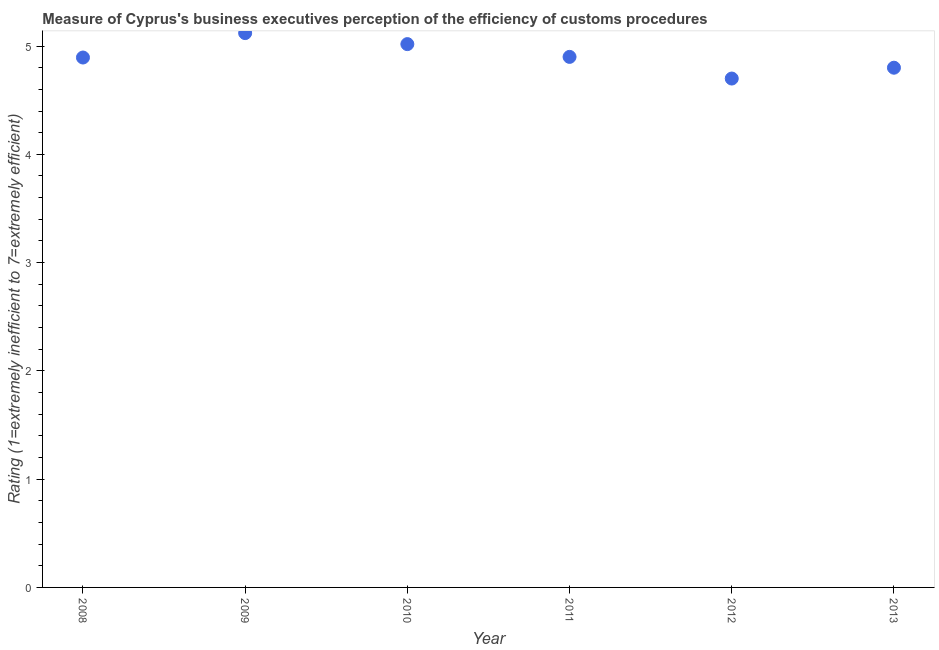What is the rating measuring burden of customs procedure in 2011?
Ensure brevity in your answer.  4.9. Across all years, what is the maximum rating measuring burden of customs procedure?
Your answer should be very brief. 5.12. Across all years, what is the minimum rating measuring burden of customs procedure?
Keep it short and to the point. 4.7. In which year was the rating measuring burden of customs procedure maximum?
Provide a short and direct response. 2009. What is the sum of the rating measuring burden of customs procedure?
Your answer should be compact. 29.43. What is the difference between the rating measuring burden of customs procedure in 2008 and 2012?
Ensure brevity in your answer.  0.19. What is the average rating measuring burden of customs procedure per year?
Make the answer very short. 4.91. What is the median rating measuring burden of customs procedure?
Offer a terse response. 4.9. What is the ratio of the rating measuring burden of customs procedure in 2008 to that in 2011?
Keep it short and to the point. 1. Is the difference between the rating measuring burden of customs procedure in 2008 and 2012 greater than the difference between any two years?
Offer a very short reply. No. What is the difference between the highest and the second highest rating measuring burden of customs procedure?
Your answer should be very brief. 0.1. What is the difference between the highest and the lowest rating measuring burden of customs procedure?
Provide a succinct answer. 0.42. How many years are there in the graph?
Your response must be concise. 6. Are the values on the major ticks of Y-axis written in scientific E-notation?
Your response must be concise. No. Does the graph contain any zero values?
Make the answer very short. No. What is the title of the graph?
Ensure brevity in your answer.  Measure of Cyprus's business executives perception of the efficiency of customs procedures. What is the label or title of the X-axis?
Make the answer very short. Year. What is the label or title of the Y-axis?
Your response must be concise. Rating (1=extremely inefficient to 7=extremely efficient). What is the Rating (1=extremely inefficient to 7=extremely efficient) in 2008?
Your answer should be compact. 4.89. What is the Rating (1=extremely inefficient to 7=extremely efficient) in 2009?
Provide a succinct answer. 5.12. What is the Rating (1=extremely inefficient to 7=extremely efficient) in 2010?
Make the answer very short. 5.02. What is the Rating (1=extremely inefficient to 7=extremely efficient) in 2011?
Your answer should be very brief. 4.9. What is the Rating (1=extremely inefficient to 7=extremely efficient) in 2012?
Keep it short and to the point. 4.7. What is the difference between the Rating (1=extremely inefficient to 7=extremely efficient) in 2008 and 2009?
Provide a short and direct response. -0.23. What is the difference between the Rating (1=extremely inefficient to 7=extremely efficient) in 2008 and 2010?
Your answer should be very brief. -0.12. What is the difference between the Rating (1=extremely inefficient to 7=extremely efficient) in 2008 and 2011?
Your answer should be compact. -0.01. What is the difference between the Rating (1=extremely inefficient to 7=extremely efficient) in 2008 and 2012?
Provide a succinct answer. 0.19. What is the difference between the Rating (1=extremely inefficient to 7=extremely efficient) in 2008 and 2013?
Your response must be concise. 0.09. What is the difference between the Rating (1=extremely inefficient to 7=extremely efficient) in 2009 and 2010?
Make the answer very short. 0.1. What is the difference between the Rating (1=extremely inefficient to 7=extremely efficient) in 2009 and 2011?
Provide a short and direct response. 0.22. What is the difference between the Rating (1=extremely inefficient to 7=extremely efficient) in 2009 and 2012?
Provide a short and direct response. 0.42. What is the difference between the Rating (1=extremely inefficient to 7=extremely efficient) in 2009 and 2013?
Keep it short and to the point. 0.32. What is the difference between the Rating (1=extremely inefficient to 7=extremely efficient) in 2010 and 2011?
Give a very brief answer. 0.12. What is the difference between the Rating (1=extremely inefficient to 7=extremely efficient) in 2010 and 2012?
Offer a very short reply. 0.32. What is the difference between the Rating (1=extremely inefficient to 7=extremely efficient) in 2010 and 2013?
Ensure brevity in your answer.  0.22. What is the difference between the Rating (1=extremely inefficient to 7=extremely efficient) in 2011 and 2013?
Offer a terse response. 0.1. What is the difference between the Rating (1=extremely inefficient to 7=extremely efficient) in 2012 and 2013?
Your answer should be very brief. -0.1. What is the ratio of the Rating (1=extremely inefficient to 7=extremely efficient) in 2008 to that in 2009?
Keep it short and to the point. 0.96. What is the ratio of the Rating (1=extremely inefficient to 7=extremely efficient) in 2008 to that in 2010?
Offer a terse response. 0.97. What is the ratio of the Rating (1=extremely inefficient to 7=extremely efficient) in 2008 to that in 2012?
Your answer should be very brief. 1.04. What is the ratio of the Rating (1=extremely inefficient to 7=extremely efficient) in 2008 to that in 2013?
Keep it short and to the point. 1.02. What is the ratio of the Rating (1=extremely inefficient to 7=extremely efficient) in 2009 to that in 2010?
Your answer should be compact. 1.02. What is the ratio of the Rating (1=extremely inefficient to 7=extremely efficient) in 2009 to that in 2011?
Make the answer very short. 1.04. What is the ratio of the Rating (1=extremely inefficient to 7=extremely efficient) in 2009 to that in 2012?
Give a very brief answer. 1.09. What is the ratio of the Rating (1=extremely inefficient to 7=extremely efficient) in 2009 to that in 2013?
Offer a terse response. 1.07. What is the ratio of the Rating (1=extremely inefficient to 7=extremely efficient) in 2010 to that in 2011?
Your answer should be compact. 1.02. What is the ratio of the Rating (1=extremely inefficient to 7=extremely efficient) in 2010 to that in 2012?
Offer a terse response. 1.07. What is the ratio of the Rating (1=extremely inefficient to 7=extremely efficient) in 2010 to that in 2013?
Keep it short and to the point. 1.04. What is the ratio of the Rating (1=extremely inefficient to 7=extremely efficient) in 2011 to that in 2012?
Provide a succinct answer. 1.04. What is the ratio of the Rating (1=extremely inefficient to 7=extremely efficient) in 2011 to that in 2013?
Ensure brevity in your answer.  1.02. What is the ratio of the Rating (1=extremely inefficient to 7=extremely efficient) in 2012 to that in 2013?
Your answer should be very brief. 0.98. 